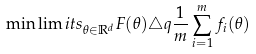<formula> <loc_0><loc_0><loc_500><loc_500>\min \lim i t s _ { \theta \in \mathbb { R } ^ { d } } F ( \theta ) \triangle q \frac { 1 } { m } \sum _ { i = 1 } ^ { m } f _ { i } ( \theta )</formula> 